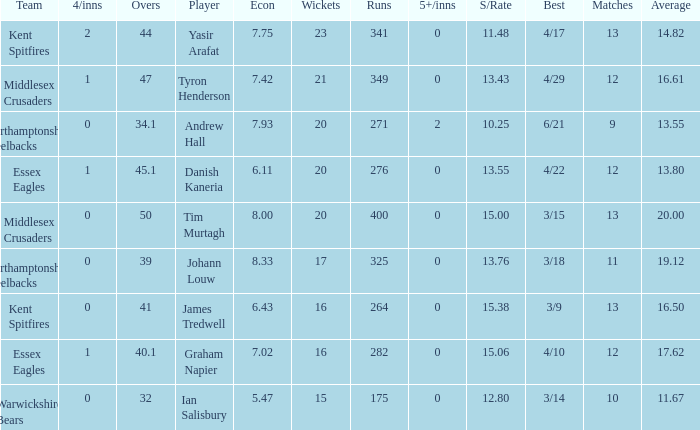Name the most 4/inns 2.0. 